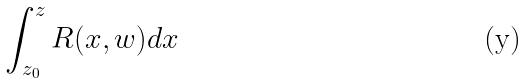<formula> <loc_0><loc_0><loc_500><loc_500>\int _ { z _ { 0 } } ^ { z } R ( x , w ) d x</formula> 